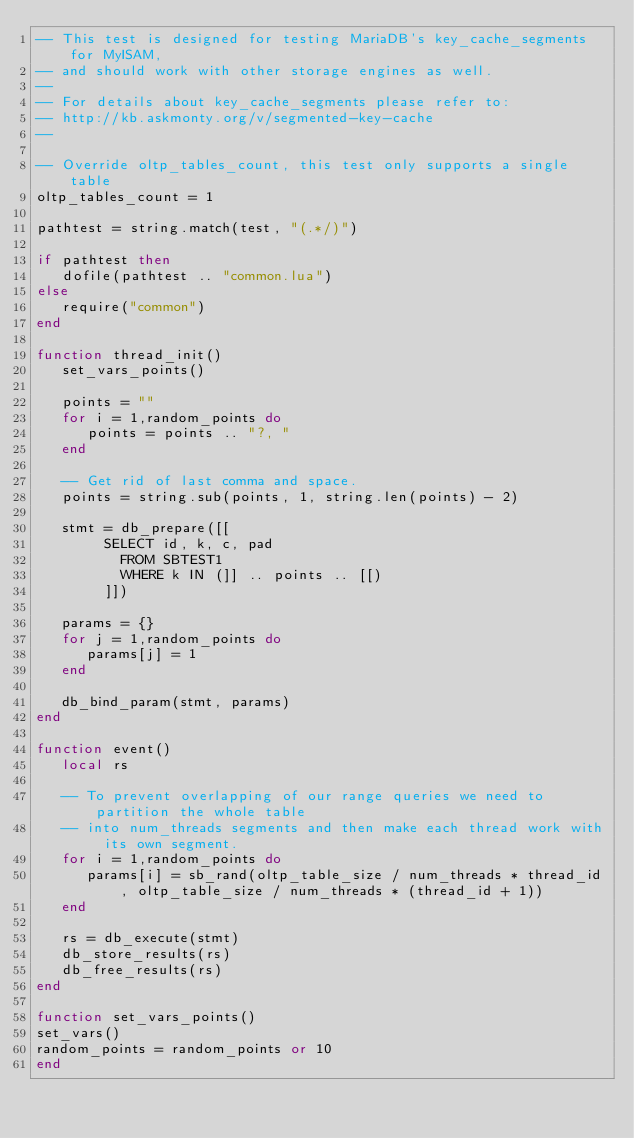<code> <loc_0><loc_0><loc_500><loc_500><_Lua_>-- This test is designed for testing MariaDB's key_cache_segments for MyISAM,
-- and should work with other storage engines as well.
--
-- For details about key_cache_segments please refer to:
-- http://kb.askmonty.org/v/segmented-key-cache
--

-- Override oltp_tables_count, this test only supports a single table
oltp_tables_count = 1

pathtest = string.match(test, "(.*/)")

if pathtest then
   dofile(pathtest .. "common.lua")
else
   require("common")
end

function thread_init()
   set_vars_points()

   points = ""
   for i = 1,random_points do
      points = points .. "?, "
   end

   -- Get rid of last comma and space.
   points = string.sub(points, 1, string.len(points) - 2)

   stmt = db_prepare([[
        SELECT id, k, c, pad
          FROM SBTEST1
          WHERE k IN (]] .. points .. [[)
        ]])

   params = {}
   for j = 1,random_points do
      params[j] = 1
   end

   db_bind_param(stmt, params)
end

function event()
   local rs

   -- To prevent overlapping of our range queries we need to partition the whole table
   -- into num_threads segments and then make each thread work with its own segment.
   for i = 1,random_points do
      params[i] = sb_rand(oltp_table_size / num_threads * thread_id, oltp_table_size / num_threads * (thread_id + 1))
   end

   rs = db_execute(stmt)
   db_store_results(rs)
   db_free_results(rs)
end

function set_vars_points()
set_vars()
random_points = random_points or 10
end
</code> 